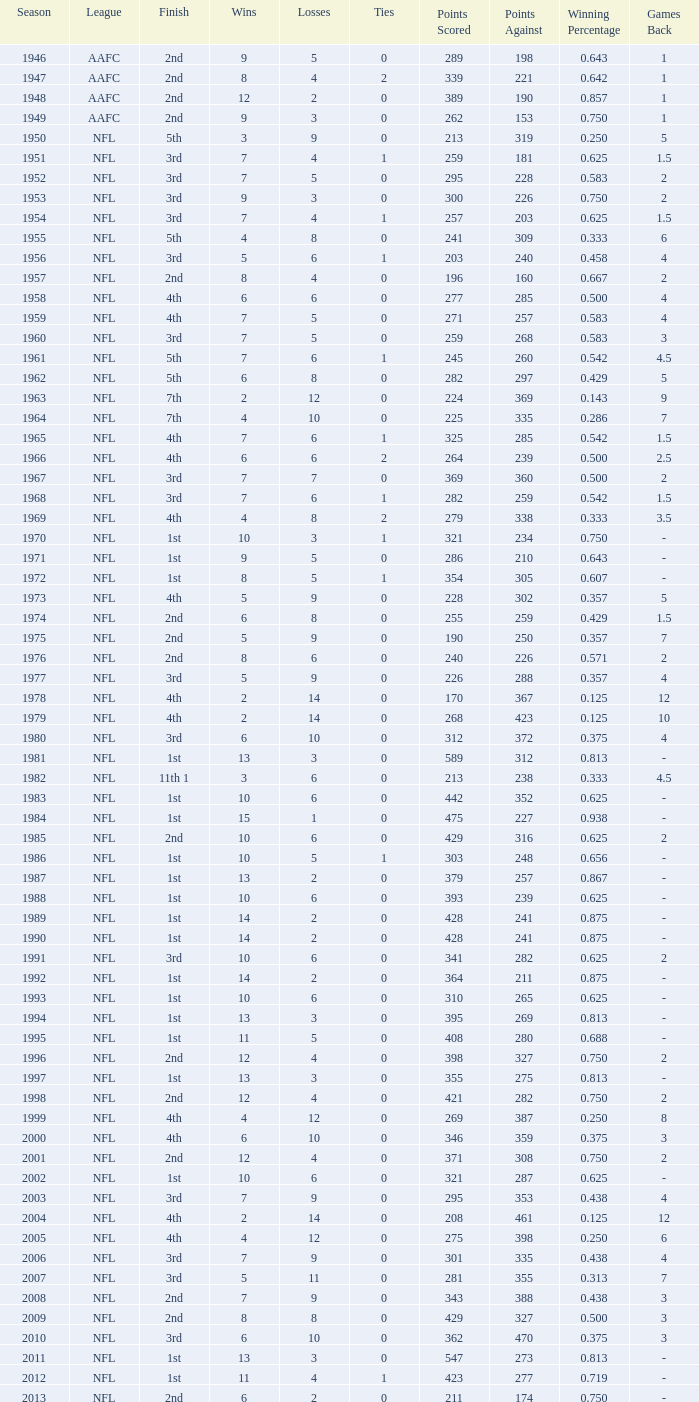What is the lowest number of ties in the NFL, with less than 2 losses and less than 15 wins? None. 